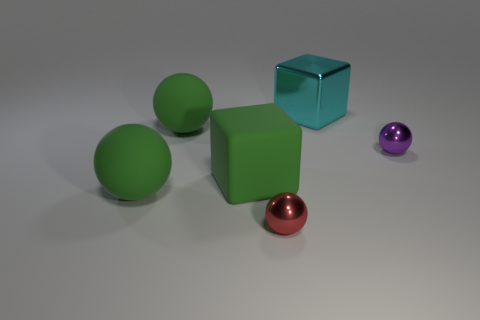Add 1 red shiny objects. How many objects exist? 7 Subtract all balls. How many objects are left? 2 Add 4 tiny red objects. How many tiny red objects are left? 5 Add 2 shiny blocks. How many shiny blocks exist? 3 Subtract 1 cyan cubes. How many objects are left? 5 Subtract all purple balls. Subtract all matte objects. How many objects are left? 2 